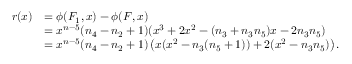Convert formula to latex. <formula><loc_0><loc_0><loc_500><loc_500>\begin{array} { r l } { r ( x ) } & { = \phi ( F _ { 1 } , x ) - \phi ( F , x ) } \\ & { = x ^ { n - 5 } ( n _ { 4 } - n _ { 2 } + 1 ) ( x ^ { 3 } + 2 x ^ { 2 } - ( n _ { 3 } + n _ { 3 } n _ { 5 } ) x - 2 n _ { 3 } n _ { 5 } ) } \\ & { = x ^ { n - 5 } ( n _ { 4 } - n _ { 2 } + 1 ) \left ( x ( x ^ { 2 } - n _ { 3 } ( n _ { 5 } + 1 ) ) + 2 ( x ^ { 2 } - n _ { 3 } n _ { 5 } ) \right ) . } \end{array}</formula> 